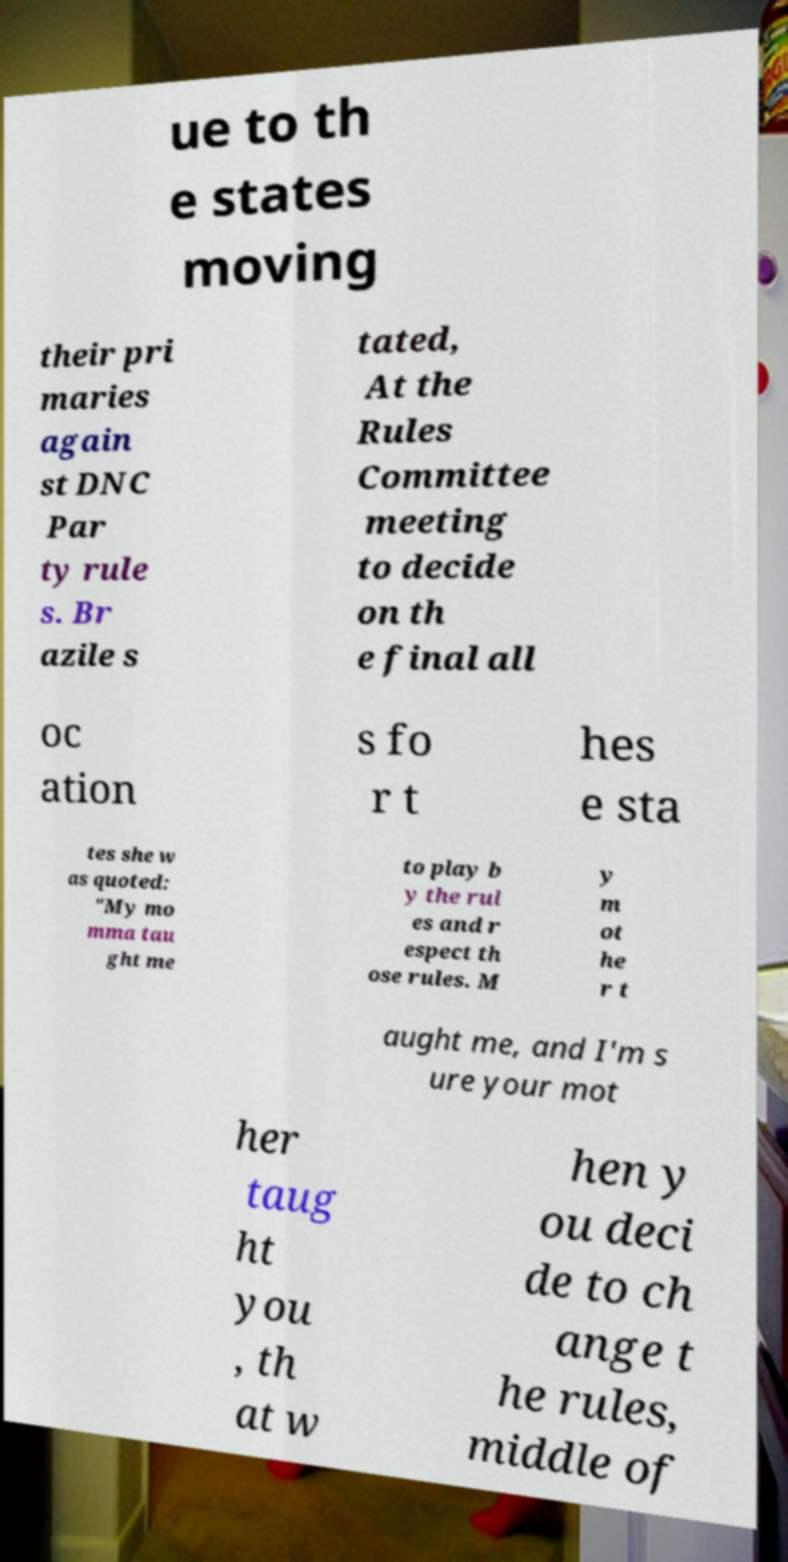Please read and relay the text visible in this image. What does it say? ue to th e states moving their pri maries again st DNC Par ty rule s. Br azile s tated, At the Rules Committee meeting to decide on th e final all oc ation s fo r t hes e sta tes she w as quoted: "My mo mma tau ght me to play b y the rul es and r espect th ose rules. M y m ot he r t aught me, and I'm s ure your mot her taug ht you , th at w hen y ou deci de to ch ange t he rules, middle of 